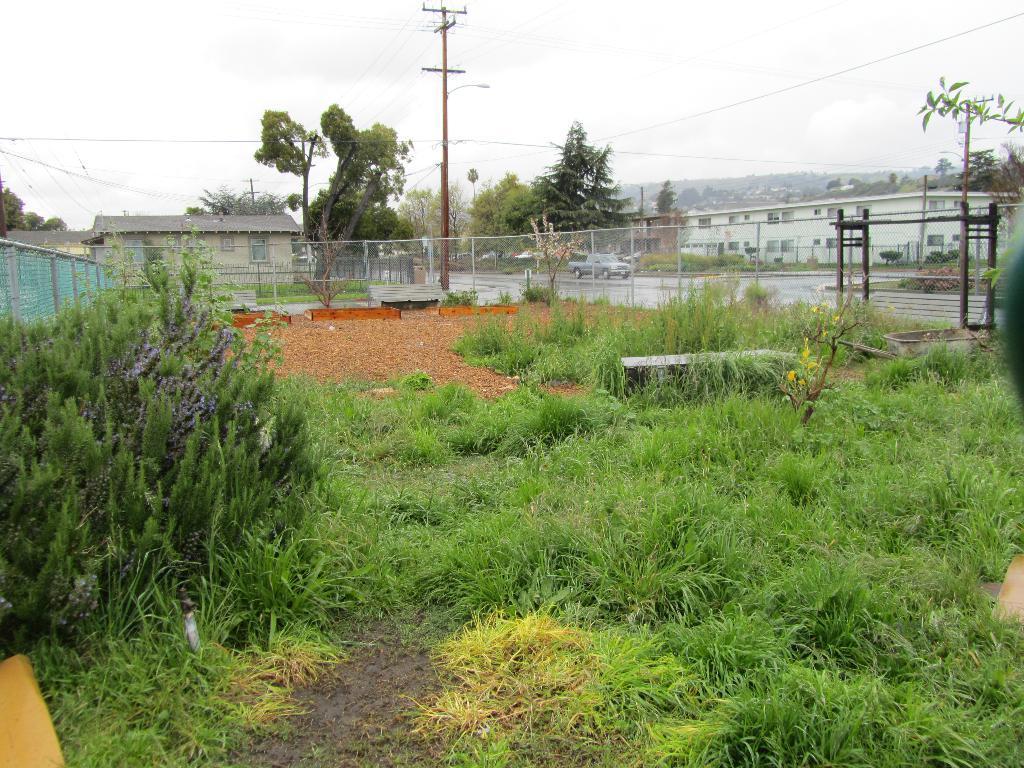In one or two sentences, can you explain what this image depicts? In this image we can see some plants and grass. on the backside we can see a fence, an utility pole with wires, trees, a house with a roof, pole and the sky which looks cloudy. 